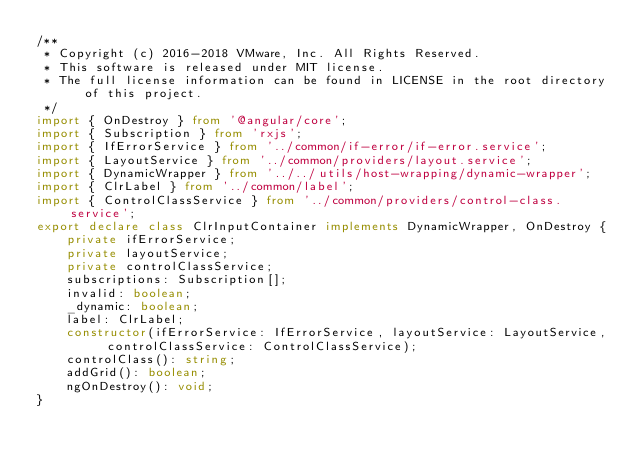Convert code to text. <code><loc_0><loc_0><loc_500><loc_500><_TypeScript_>/**
 * Copyright (c) 2016-2018 VMware, Inc. All Rights Reserved.
 * This software is released under MIT license.
 * The full license information can be found in LICENSE in the root directory of this project.
 */
import { OnDestroy } from '@angular/core';
import { Subscription } from 'rxjs';
import { IfErrorService } from '../common/if-error/if-error.service';
import { LayoutService } from '../common/providers/layout.service';
import { DynamicWrapper } from '../../utils/host-wrapping/dynamic-wrapper';
import { ClrLabel } from '../common/label';
import { ControlClassService } from '../common/providers/control-class.service';
export declare class ClrInputContainer implements DynamicWrapper, OnDestroy {
    private ifErrorService;
    private layoutService;
    private controlClassService;
    subscriptions: Subscription[];
    invalid: boolean;
    _dynamic: boolean;
    label: ClrLabel;
    constructor(ifErrorService: IfErrorService, layoutService: LayoutService, controlClassService: ControlClassService);
    controlClass(): string;
    addGrid(): boolean;
    ngOnDestroy(): void;
}
</code> 